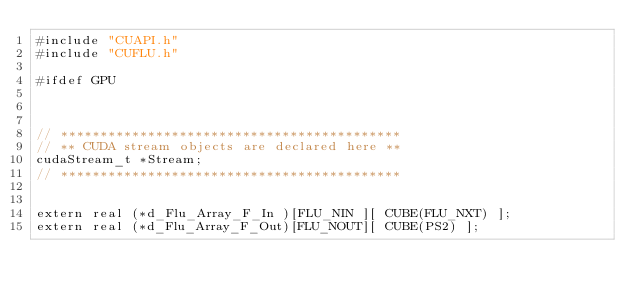Convert code to text. <code><loc_0><loc_0><loc_500><loc_500><_Cuda_>#include "CUAPI.h"
#include "CUFLU.h"

#ifdef GPU



// *******************************************
// ** CUDA stream objects are declared here **
cudaStream_t *Stream;
// *******************************************


extern real (*d_Flu_Array_F_In )[FLU_NIN ][ CUBE(FLU_NXT) ];
extern real (*d_Flu_Array_F_Out)[FLU_NOUT][ CUBE(PS2) ];</code> 